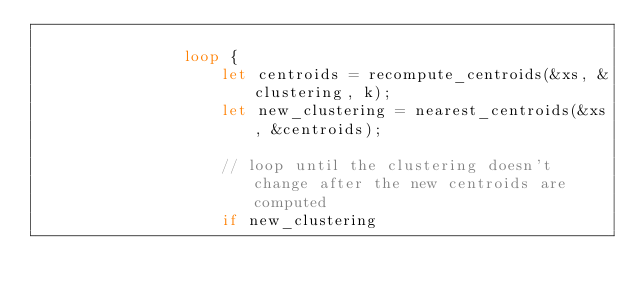Convert code to text. <code><loc_0><loc_0><loc_500><loc_500><_Rust_>
                loop {
                    let centroids = recompute_centroids(&xs, &clustering, k);
                    let new_clustering = nearest_centroids(&xs, &centroids);

                    // loop until the clustering doesn't change after the new centroids are computed
                    if new_clustering</code> 